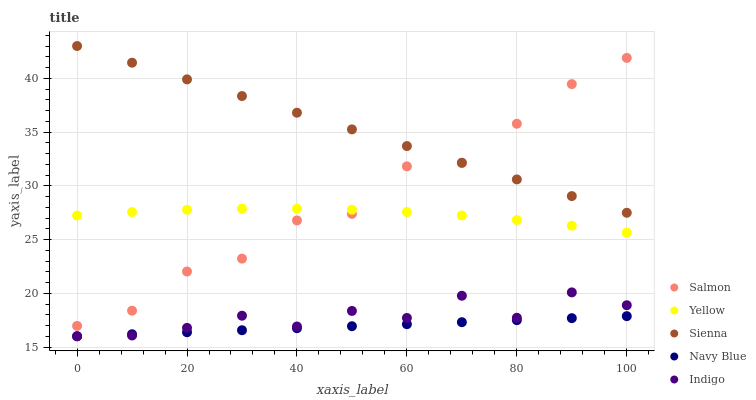Does Navy Blue have the minimum area under the curve?
Answer yes or no. Yes. Does Sienna have the maximum area under the curve?
Answer yes or no. Yes. Does Salmon have the minimum area under the curve?
Answer yes or no. No. Does Salmon have the maximum area under the curve?
Answer yes or no. No. Is Navy Blue the smoothest?
Answer yes or no. Yes. Is Indigo the roughest?
Answer yes or no. Yes. Is Salmon the smoothest?
Answer yes or no. No. Is Salmon the roughest?
Answer yes or no. No. Does Navy Blue have the lowest value?
Answer yes or no. Yes. Does Salmon have the lowest value?
Answer yes or no. No. Does Sienna have the highest value?
Answer yes or no. Yes. Does Salmon have the highest value?
Answer yes or no. No. Is Indigo less than Yellow?
Answer yes or no. Yes. Is Sienna greater than Yellow?
Answer yes or no. Yes. Does Salmon intersect Yellow?
Answer yes or no. Yes. Is Salmon less than Yellow?
Answer yes or no. No. Is Salmon greater than Yellow?
Answer yes or no. No. Does Indigo intersect Yellow?
Answer yes or no. No. 